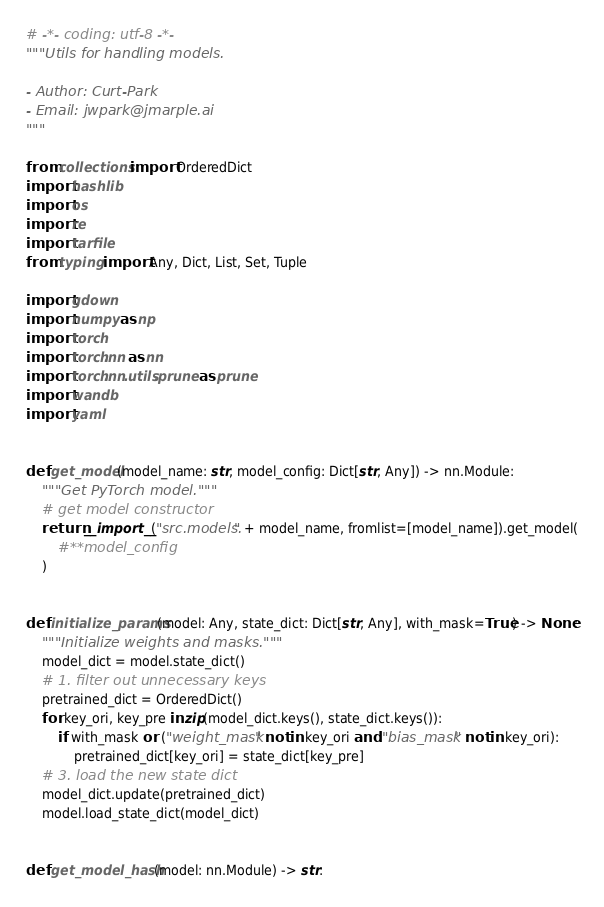<code> <loc_0><loc_0><loc_500><loc_500><_Python_># -*- coding: utf-8 -*-
"""Utils for handling models.

- Author: Curt-Park
- Email: jwpark@jmarple.ai
"""

from collections import OrderedDict
import hashlib
import os
import re
import tarfile
from typing import Any, Dict, List, Set, Tuple

import gdown
import numpy as np
import torch
import torch.nn as nn
import torch.nn.utils.prune as prune
import wandb
import yaml


def get_model(model_name: str, model_config: Dict[str, Any]) -> nn.Module:
    """Get PyTorch model."""
    # get model constructor
    return __import__("src.models." + model_name, fromlist=[model_name]).get_model(
        #**model_config
    )


def initialize_params(model: Any, state_dict: Dict[str, Any], with_mask=True) -> None:
    """Initialize weights and masks."""
    model_dict = model.state_dict()
    # 1. filter out unnecessary keys
    pretrained_dict = OrderedDict()
    for key_ori, key_pre in zip(model_dict.keys(), state_dict.keys()):
        if with_mask or ("weight_mask" not in key_ori and "bias_mask" not in key_ori):
            pretrained_dict[key_ori] = state_dict[key_pre]
    # 3. load the new state dict
    model_dict.update(pretrained_dict)
    model.load_state_dict(model_dict)


def get_model_hash(model: nn.Module) -> str:</code> 